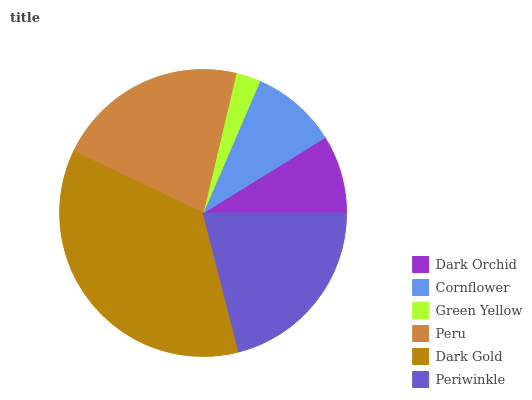Is Green Yellow the minimum?
Answer yes or no. Yes. Is Dark Gold the maximum?
Answer yes or no. Yes. Is Cornflower the minimum?
Answer yes or no. No. Is Cornflower the maximum?
Answer yes or no. No. Is Cornflower greater than Dark Orchid?
Answer yes or no. Yes. Is Dark Orchid less than Cornflower?
Answer yes or no. Yes. Is Dark Orchid greater than Cornflower?
Answer yes or no. No. Is Cornflower less than Dark Orchid?
Answer yes or no. No. Is Periwinkle the high median?
Answer yes or no. Yes. Is Cornflower the low median?
Answer yes or no. Yes. Is Green Yellow the high median?
Answer yes or no. No. Is Peru the low median?
Answer yes or no. No. 